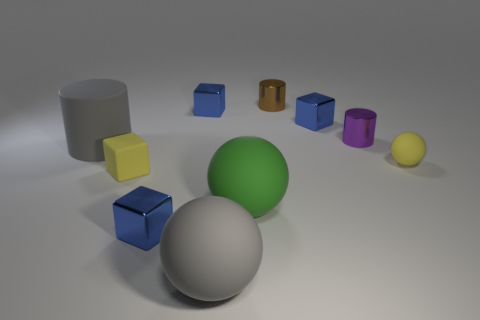What is the shape of the large gray rubber thing behind the blue block in front of the small yellow thing that is right of the purple cylinder?
Offer a terse response. Cylinder. Is the size of the gray cylinder the same as the green object left of the small brown metallic cylinder?
Your answer should be very brief. Yes. There is a tiny blue thing that is left of the large gray sphere and behind the large matte cylinder; what shape is it?
Keep it short and to the point. Cube. How many small things are blue blocks or gray cylinders?
Keep it short and to the point. 3. Is the number of small rubber things behind the brown cylinder the same as the number of tiny purple metallic cylinders that are left of the large matte cylinder?
Offer a terse response. Yes. How many other things are the same color as the matte cylinder?
Ensure brevity in your answer.  1. Are there the same number of tiny things left of the tiny yellow cube and large brown matte cylinders?
Your response must be concise. Yes. Is the size of the brown metallic cylinder the same as the yellow cube?
Ensure brevity in your answer.  Yes. What material is the block that is on the right side of the tiny yellow matte cube and in front of the large cylinder?
Ensure brevity in your answer.  Metal. What number of small yellow objects are the same shape as the large green matte object?
Make the answer very short. 1. 